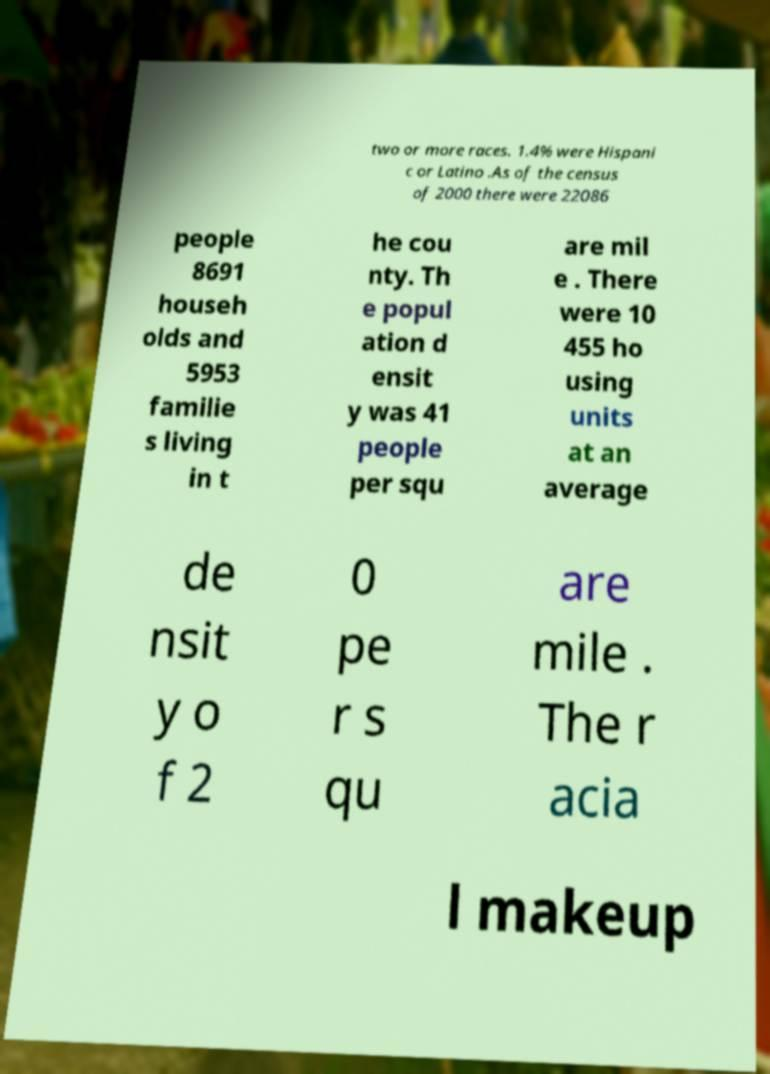What messages or text are displayed in this image? I need them in a readable, typed format. two or more races. 1.4% were Hispani c or Latino .As of the census of 2000 there were 22086 people 8691 househ olds and 5953 familie s living in t he cou nty. Th e popul ation d ensit y was 41 people per squ are mil e . There were 10 455 ho using units at an average de nsit y o f 2 0 pe r s qu are mile . The r acia l makeup 